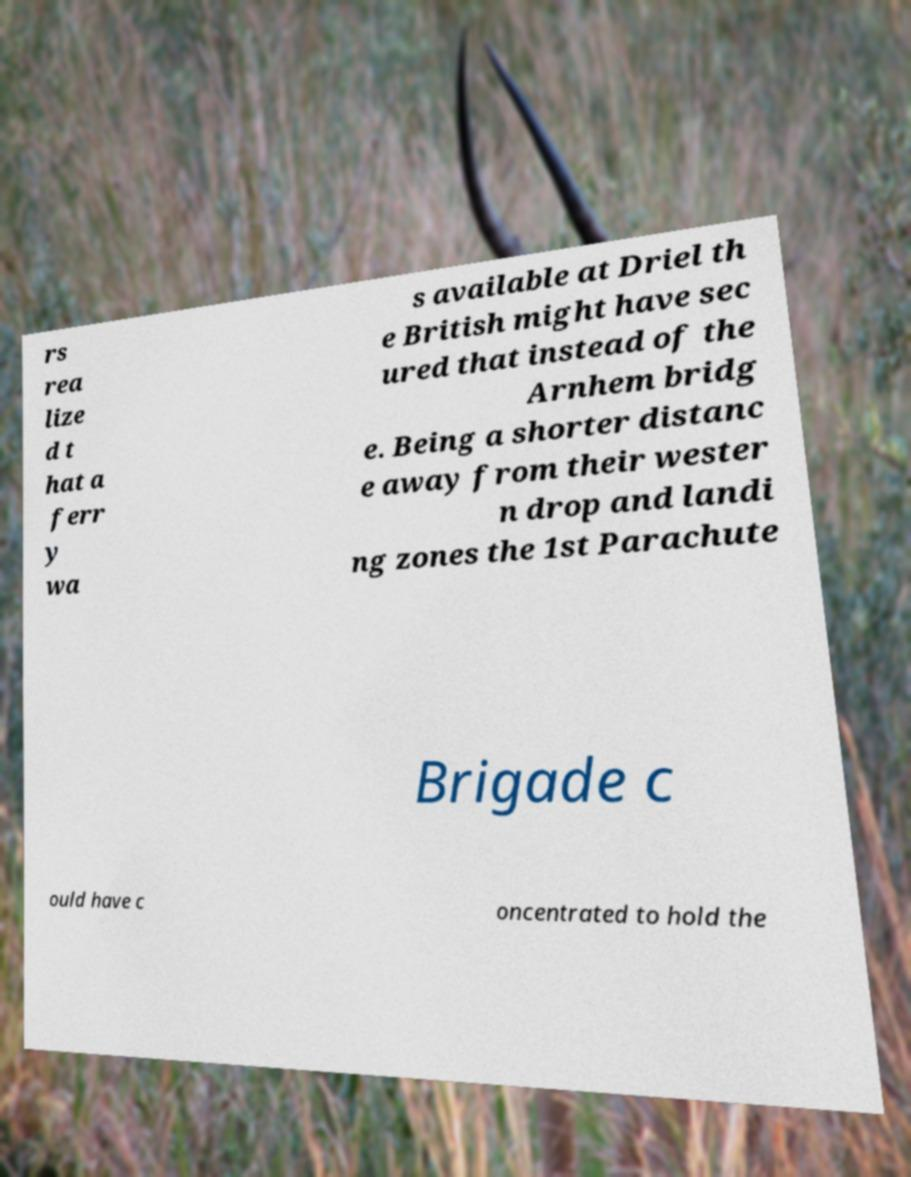Can you read and provide the text displayed in the image?This photo seems to have some interesting text. Can you extract and type it out for me? rs rea lize d t hat a ferr y wa s available at Driel th e British might have sec ured that instead of the Arnhem bridg e. Being a shorter distanc e away from their wester n drop and landi ng zones the 1st Parachute Brigade c ould have c oncentrated to hold the 